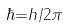<formula> <loc_0><loc_0><loc_500><loc_500>\hbar { = } { h } / { 2 \pi }</formula> 